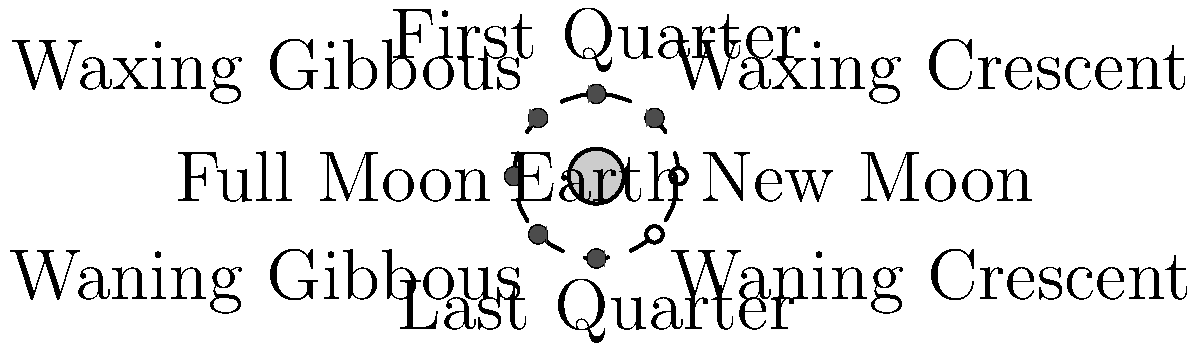As a judge who regularly consults with parole officers, you understand the importance of careful observation and analysis. In the context of lunar phases, which phase would be most visible to an observer on Earth at midnight, and why is this significant for understanding cyclical patterns? To answer this question, let's break down the lunar phases and their visibility from Earth:

1. The lunar cycle is approximately 29.5 days long, during which the Moon goes through various phases.

2. The phases are determined by the relative positions of the Sun, Earth, and Moon.

3. At midnight, the observer on Earth is facing away from the Sun.

4. The Full Moon phase occurs when the Moon is on the opposite side of Earth from the Sun, making it fully illuminated from Earth's perspective.

5. During the Full Moon phase:
   a) The Moon rises at sunset
   b) It is highest in the sky around midnight
   c) It sets at sunrise

6. This makes the Full Moon the most visible phase at midnight.

7. The significance of understanding this pattern:
   a) It demonstrates the predictable nature of celestial cycles
   b) It illustrates how the positions of celestial bodies affect our observations
   c) It provides a framework for understanding other cyclical patterns in nature and society

8. For a judge working with parole cases, this understanding of cycles and patterns can be metaphorically applied to:
   a) Recognizing patterns in human behavior
   b) Appreciating the importance of timing in decision-making
   c) Understanding how external factors can influence visibility and perception

By recognizing the Full Moon as the most visible phase at midnight, we gain insight into the interconnectedness of celestial bodies and the importance of perspective in observation – principles that can be applied broadly in various fields, including law and rehabilitation.
Answer: Full Moon 